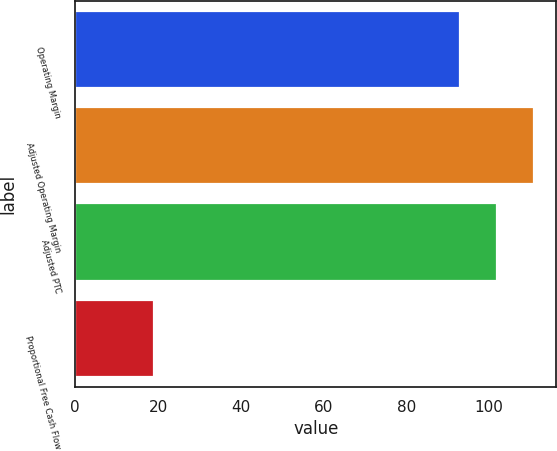Convert chart. <chart><loc_0><loc_0><loc_500><loc_500><bar_chart><fcel>Operating Margin<fcel>Adjusted Operating Margin<fcel>Adjusted PTC<fcel>Proportional Free Cash Flow<nl><fcel>93<fcel>110.8<fcel>101.9<fcel>19<nl></chart> 